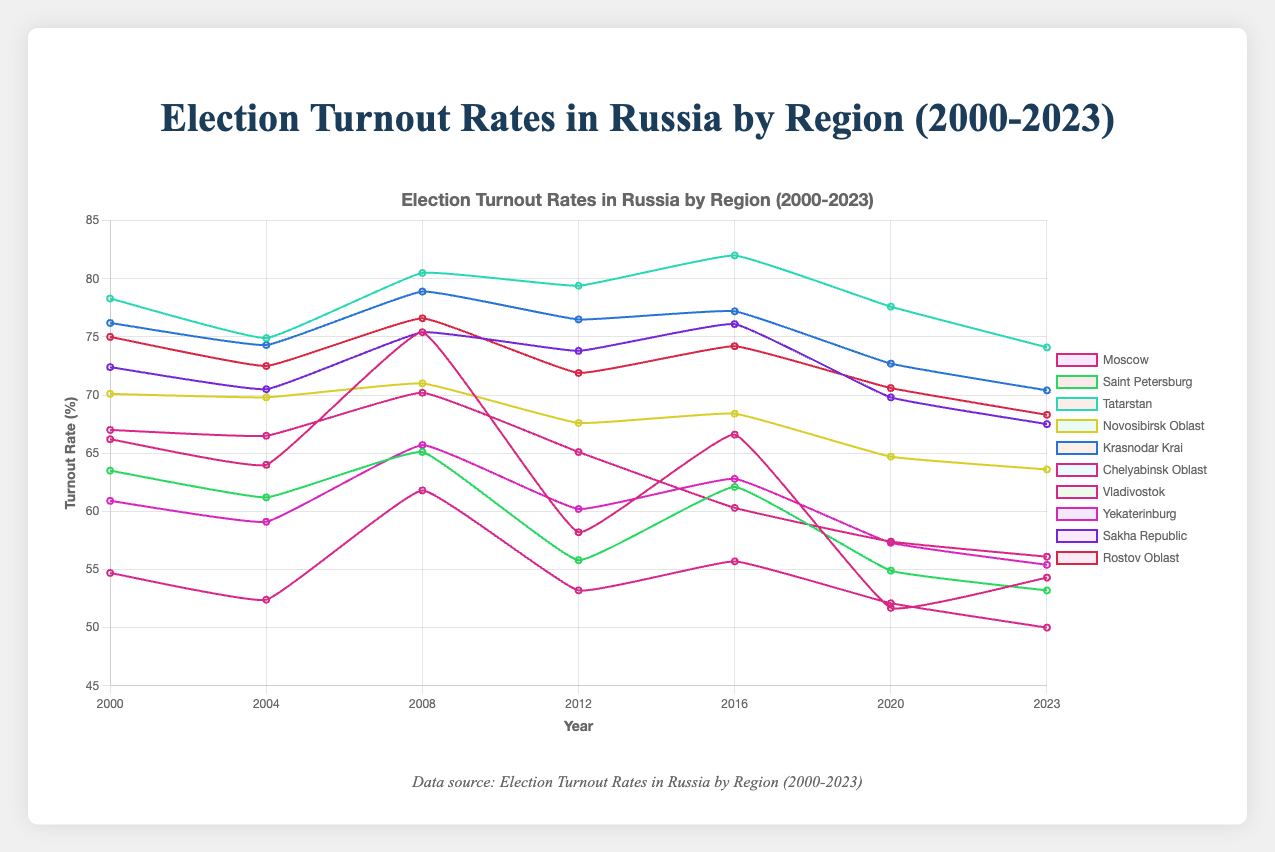Which region had the highest turnout rate in 2000? By looking at the data points on the graph for the year 2000, we can observe that Tatarstan had the highest turnout rate, being at 78.3%.
Answer: Tatarstan What is the difference in turnout rates between Moscow and Saint Petersburg in 2023? In 2023, the turnout rate for Moscow is 54.3%, and for Saint Petersburg, it is 53.2%. Subtracting the two gives us: 54.3% - 53.2% = 1.1%.
Answer: 1.1% Which region had the largest decrease in turnout from 2000 to 2023? By comparing the turnout rates in 2000 and 2023 for each region, we see that Moscow had a turnout of 66.2% in 2000 and 54.3% in 2023. This is a decrease of: 66.2% - 54.3% = 11.9%, which is the highest decrease seen across all regions.
Answer: Moscow What was the average turnout rate for Tatarstan over the years? Tatarstan's turnout rates are: 78.3 (2000), 74.9 (2004), 80.5 (2008), 79.4 (2012), 82.0 (2016), 77.6 (2020), 74.1 (2023). Summing these: 78.3 + 74.9 + 80.5 + 79.4 + 82.0 + 77.6 + 74.1 = 546.8. Dividing by the number of data points (7) gives: 546.8 / 7 ≈ 78.11%.
Answer: 78.11% Which region shows the most consistent turnout rates, and how is this determined? Consistency can be measured by finding the standard deviation of the turnout rates for each region. Comparing the standard deviations, Rosov Oblast shows the least variability. Visual inspection further confirms it doesn't have large fluctuations.
Answer: Rostov Oblast How many regions had a turnout rate above 70% in 2016? By looking at the plotted data for the year 2016, the regions with turnout rates above 70% are Tatarstan (82.0%), Krasnodar Krai (77.2%), Sakha Republic (76.1%), and Rostov Oblast (74.2%). Thus, four regions had above 70%.
Answer: 4 In which year did Chelyabinsk Oblast experience its lowest turnout rate, and what was it? Observing the data points for Chelyabinsk Oblast, its lowest turnout rate occurred in 2023, with a rate of 56.1%.
Answer: 2023, 56.1% Comparing the turnout trends of Vladivostok and Yekaterinburg, which region showed a general increasing or decreasing trend? Vladivostok shows a generally decreasing trend from 2000 (54.7%) to 2023 (50.0%), while Yekaterinburg also shows a decreasing trend from 2000 (60.9%) to 2023 (55.4%). Thus, both regions showed a decreasing trend.
Answer: Both decreasing 